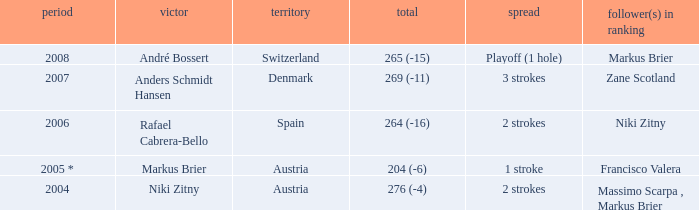What was the country when the margin was 2 strokes, and when the score was 276 (-4)? Austria. 